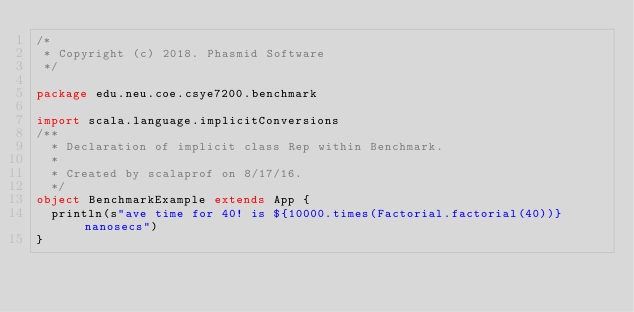Convert code to text. <code><loc_0><loc_0><loc_500><loc_500><_Scala_>/*
 * Copyright (c) 2018. Phasmid Software
 */

package edu.neu.coe.csye7200.benchmark

import scala.language.implicitConversions
/**
  * Declaration of implicit class Rep within Benchmark.
  *
  * Created by scalaprof on 8/17/16.
  */
object BenchmarkExample extends App {
  println(s"ave time for 40! is ${10000.times(Factorial.factorial(40))} nanosecs")
}
</code> 